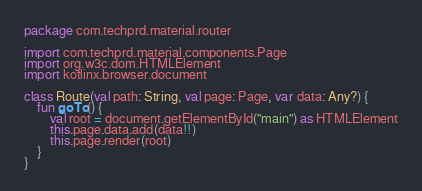Convert code to text. <code><loc_0><loc_0><loc_500><loc_500><_Kotlin_>package com.techprd.material.router

import com.techprd.material.components.Page
import org.w3c.dom.HTMLElement
import kotlinx.browser.document

class Route(val path: String, val page: Page, var data: Any?) {
    fun goTo() {
        val root = document.getElementById("main") as HTMLElement
        this.page.data.add(data!!)
        this.page.render(root)
    }
}
</code> 